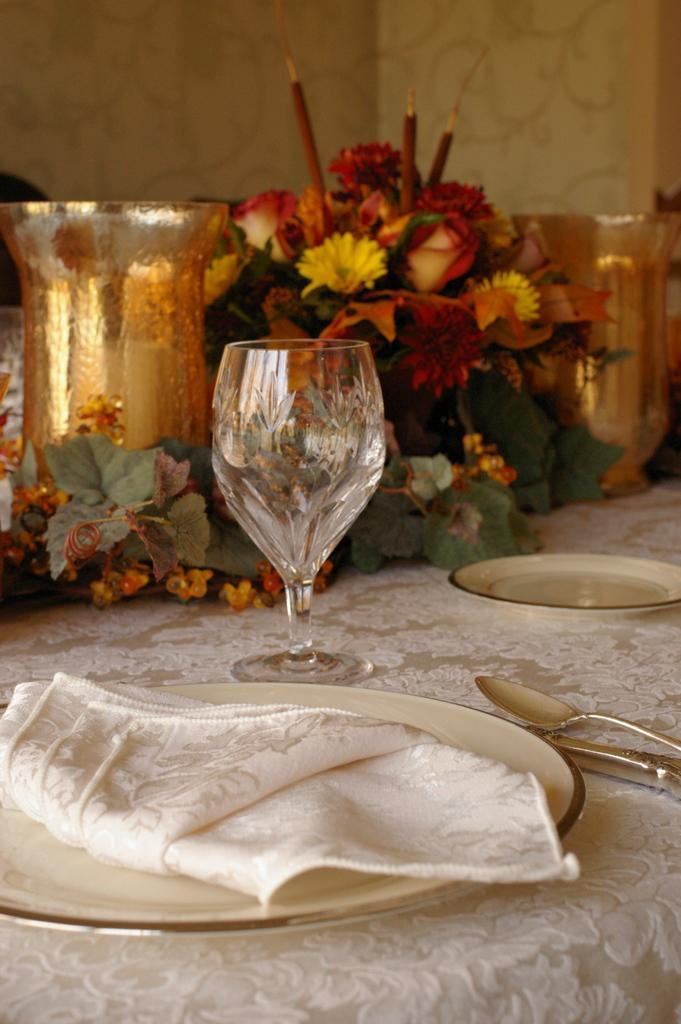Can you describe this image briefly? There are plates, Spoons,wine glass,flowers on the dining table. 